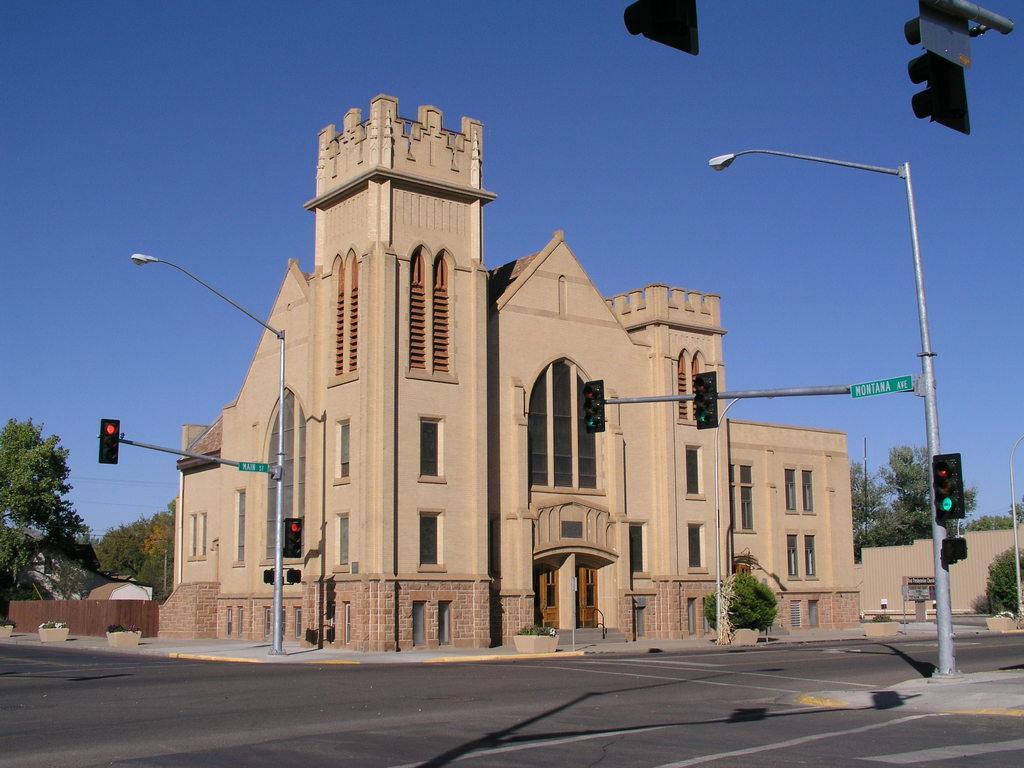In one or two sentences, can you explain what this image depicts? At the bottom of this image there is a road. On both sides of the road I can see traffic signal poles and street lights. In the background there is a building and I can see the trees. On the top of the image I can see the sky in blue color. 